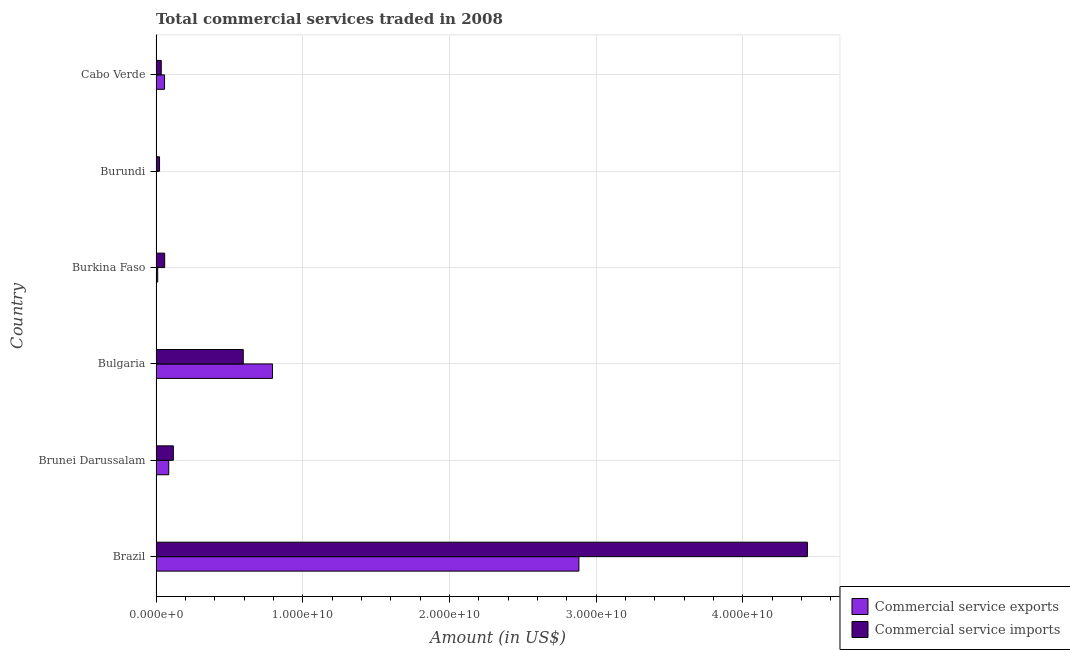How many bars are there on the 5th tick from the bottom?
Offer a terse response. 2. What is the label of the 6th group of bars from the top?
Your answer should be compact. Brazil. What is the amount of commercial service exports in Brazil?
Give a very brief answer. 2.88e+1. Across all countries, what is the maximum amount of commercial service exports?
Provide a short and direct response. 2.88e+1. Across all countries, what is the minimum amount of commercial service exports?
Offer a very short reply. 3.25e+06. In which country was the amount of commercial service exports minimum?
Ensure brevity in your answer.  Burundi. What is the total amount of commercial service imports in the graph?
Offer a terse response. 5.27e+1. What is the difference between the amount of commercial service imports in Brunei Darussalam and that in Burundi?
Your response must be concise. 9.41e+08. What is the difference between the amount of commercial service exports in Burkina Faso and the amount of commercial service imports in Cabo Verde?
Your answer should be compact. -2.42e+08. What is the average amount of commercial service imports per country?
Make the answer very short. 8.79e+09. What is the difference between the amount of commercial service imports and amount of commercial service exports in Cabo Verde?
Ensure brevity in your answer.  -2.24e+08. In how many countries, is the amount of commercial service exports greater than 36000000000 US$?
Keep it short and to the point. 0. What is the ratio of the amount of commercial service exports in Bulgaria to that in Burkina Faso?
Provide a short and direct response. 69.1. What is the difference between the highest and the second highest amount of commercial service exports?
Your answer should be very brief. 2.09e+1. What is the difference between the highest and the lowest amount of commercial service exports?
Provide a succinct answer. 2.88e+1. Is the sum of the amount of commercial service imports in Burkina Faso and Burundi greater than the maximum amount of commercial service exports across all countries?
Provide a succinct answer. No. What does the 1st bar from the top in Brazil represents?
Your answer should be compact. Commercial service imports. What does the 1st bar from the bottom in Cabo Verde represents?
Make the answer very short. Commercial service exports. How many countries are there in the graph?
Your answer should be very brief. 6. What is the difference between two consecutive major ticks on the X-axis?
Your answer should be compact. 1.00e+1. Are the values on the major ticks of X-axis written in scientific E-notation?
Provide a succinct answer. Yes. Does the graph contain any zero values?
Offer a terse response. No. Does the graph contain grids?
Your answer should be very brief. Yes. Where does the legend appear in the graph?
Provide a short and direct response. Bottom right. How are the legend labels stacked?
Give a very brief answer. Vertical. What is the title of the graph?
Make the answer very short. Total commercial services traded in 2008. What is the label or title of the Y-axis?
Your response must be concise. Country. What is the Amount (in US$) of Commercial service exports in Brazil?
Make the answer very short. 2.88e+1. What is the Amount (in US$) of Commercial service imports in Brazil?
Give a very brief answer. 4.44e+1. What is the Amount (in US$) of Commercial service exports in Brunei Darussalam?
Ensure brevity in your answer.  8.67e+08. What is the Amount (in US$) of Commercial service imports in Brunei Darussalam?
Give a very brief answer. 1.18e+09. What is the Amount (in US$) of Commercial service exports in Bulgaria?
Provide a succinct answer. 7.94e+09. What is the Amount (in US$) in Commercial service imports in Bulgaria?
Make the answer very short. 5.95e+09. What is the Amount (in US$) of Commercial service exports in Burkina Faso?
Offer a very short reply. 1.15e+08. What is the Amount (in US$) in Commercial service imports in Burkina Faso?
Your answer should be very brief. 5.90e+08. What is the Amount (in US$) of Commercial service exports in Burundi?
Provide a succinct answer. 3.25e+06. What is the Amount (in US$) of Commercial service imports in Burundi?
Offer a very short reply. 2.41e+08. What is the Amount (in US$) in Commercial service exports in Cabo Verde?
Offer a very short reply. 5.81e+08. What is the Amount (in US$) of Commercial service imports in Cabo Verde?
Your answer should be compact. 3.57e+08. Across all countries, what is the maximum Amount (in US$) in Commercial service exports?
Offer a very short reply. 2.88e+1. Across all countries, what is the maximum Amount (in US$) of Commercial service imports?
Offer a very short reply. 4.44e+1. Across all countries, what is the minimum Amount (in US$) in Commercial service exports?
Your response must be concise. 3.25e+06. Across all countries, what is the minimum Amount (in US$) of Commercial service imports?
Provide a succinct answer. 2.41e+08. What is the total Amount (in US$) in Commercial service exports in the graph?
Ensure brevity in your answer.  3.83e+1. What is the total Amount (in US$) of Commercial service imports in the graph?
Your answer should be compact. 5.27e+1. What is the difference between the Amount (in US$) in Commercial service exports in Brazil and that in Brunei Darussalam?
Keep it short and to the point. 2.80e+1. What is the difference between the Amount (in US$) of Commercial service imports in Brazil and that in Brunei Darussalam?
Ensure brevity in your answer.  4.32e+1. What is the difference between the Amount (in US$) of Commercial service exports in Brazil and that in Bulgaria?
Keep it short and to the point. 2.09e+1. What is the difference between the Amount (in US$) in Commercial service imports in Brazil and that in Bulgaria?
Make the answer very short. 3.85e+1. What is the difference between the Amount (in US$) in Commercial service exports in Brazil and that in Burkina Faso?
Offer a terse response. 2.87e+1. What is the difference between the Amount (in US$) in Commercial service imports in Brazil and that in Burkina Faso?
Ensure brevity in your answer.  4.38e+1. What is the difference between the Amount (in US$) of Commercial service exports in Brazil and that in Burundi?
Your answer should be compact. 2.88e+1. What is the difference between the Amount (in US$) of Commercial service imports in Brazil and that in Burundi?
Offer a very short reply. 4.42e+1. What is the difference between the Amount (in US$) of Commercial service exports in Brazil and that in Cabo Verde?
Give a very brief answer. 2.82e+1. What is the difference between the Amount (in US$) in Commercial service imports in Brazil and that in Cabo Verde?
Offer a terse response. 4.40e+1. What is the difference between the Amount (in US$) in Commercial service exports in Brunei Darussalam and that in Bulgaria?
Give a very brief answer. -7.07e+09. What is the difference between the Amount (in US$) in Commercial service imports in Brunei Darussalam and that in Bulgaria?
Keep it short and to the point. -4.76e+09. What is the difference between the Amount (in US$) of Commercial service exports in Brunei Darussalam and that in Burkina Faso?
Ensure brevity in your answer.  7.52e+08. What is the difference between the Amount (in US$) of Commercial service imports in Brunei Darussalam and that in Burkina Faso?
Provide a short and direct response. 5.91e+08. What is the difference between the Amount (in US$) of Commercial service exports in Brunei Darussalam and that in Burundi?
Your answer should be very brief. 8.64e+08. What is the difference between the Amount (in US$) of Commercial service imports in Brunei Darussalam and that in Burundi?
Offer a very short reply. 9.41e+08. What is the difference between the Amount (in US$) in Commercial service exports in Brunei Darussalam and that in Cabo Verde?
Ensure brevity in your answer.  2.86e+08. What is the difference between the Amount (in US$) in Commercial service imports in Brunei Darussalam and that in Cabo Verde?
Your answer should be very brief. 8.24e+08. What is the difference between the Amount (in US$) in Commercial service exports in Bulgaria and that in Burkina Faso?
Provide a succinct answer. 7.82e+09. What is the difference between the Amount (in US$) in Commercial service imports in Bulgaria and that in Burkina Faso?
Your response must be concise. 5.36e+09. What is the difference between the Amount (in US$) of Commercial service exports in Bulgaria and that in Burundi?
Make the answer very short. 7.94e+09. What is the difference between the Amount (in US$) in Commercial service imports in Bulgaria and that in Burundi?
Your response must be concise. 5.70e+09. What is the difference between the Amount (in US$) of Commercial service exports in Bulgaria and that in Cabo Verde?
Your response must be concise. 7.36e+09. What is the difference between the Amount (in US$) of Commercial service imports in Bulgaria and that in Cabo Verde?
Ensure brevity in your answer.  5.59e+09. What is the difference between the Amount (in US$) of Commercial service exports in Burkina Faso and that in Burundi?
Provide a short and direct response. 1.12e+08. What is the difference between the Amount (in US$) in Commercial service imports in Burkina Faso and that in Burundi?
Your answer should be compact. 3.50e+08. What is the difference between the Amount (in US$) in Commercial service exports in Burkina Faso and that in Cabo Verde?
Provide a succinct answer. -4.66e+08. What is the difference between the Amount (in US$) of Commercial service imports in Burkina Faso and that in Cabo Verde?
Provide a succinct answer. 2.33e+08. What is the difference between the Amount (in US$) in Commercial service exports in Burundi and that in Cabo Verde?
Give a very brief answer. -5.78e+08. What is the difference between the Amount (in US$) in Commercial service imports in Burundi and that in Cabo Verde?
Offer a terse response. -1.16e+08. What is the difference between the Amount (in US$) of Commercial service exports in Brazil and the Amount (in US$) of Commercial service imports in Brunei Darussalam?
Offer a very short reply. 2.76e+1. What is the difference between the Amount (in US$) of Commercial service exports in Brazil and the Amount (in US$) of Commercial service imports in Bulgaria?
Make the answer very short. 2.29e+1. What is the difference between the Amount (in US$) in Commercial service exports in Brazil and the Amount (in US$) in Commercial service imports in Burkina Faso?
Make the answer very short. 2.82e+1. What is the difference between the Amount (in US$) of Commercial service exports in Brazil and the Amount (in US$) of Commercial service imports in Burundi?
Provide a short and direct response. 2.86e+1. What is the difference between the Amount (in US$) in Commercial service exports in Brazil and the Amount (in US$) in Commercial service imports in Cabo Verde?
Make the answer very short. 2.85e+1. What is the difference between the Amount (in US$) in Commercial service exports in Brunei Darussalam and the Amount (in US$) in Commercial service imports in Bulgaria?
Your answer should be compact. -5.08e+09. What is the difference between the Amount (in US$) of Commercial service exports in Brunei Darussalam and the Amount (in US$) of Commercial service imports in Burkina Faso?
Your answer should be compact. 2.77e+08. What is the difference between the Amount (in US$) in Commercial service exports in Brunei Darussalam and the Amount (in US$) in Commercial service imports in Burundi?
Provide a short and direct response. 6.27e+08. What is the difference between the Amount (in US$) of Commercial service exports in Brunei Darussalam and the Amount (in US$) of Commercial service imports in Cabo Verde?
Provide a succinct answer. 5.10e+08. What is the difference between the Amount (in US$) in Commercial service exports in Bulgaria and the Amount (in US$) in Commercial service imports in Burkina Faso?
Your answer should be very brief. 7.35e+09. What is the difference between the Amount (in US$) of Commercial service exports in Bulgaria and the Amount (in US$) of Commercial service imports in Burundi?
Your response must be concise. 7.70e+09. What is the difference between the Amount (in US$) of Commercial service exports in Bulgaria and the Amount (in US$) of Commercial service imports in Cabo Verde?
Your response must be concise. 7.58e+09. What is the difference between the Amount (in US$) in Commercial service exports in Burkina Faso and the Amount (in US$) in Commercial service imports in Burundi?
Your answer should be very brief. -1.26e+08. What is the difference between the Amount (in US$) in Commercial service exports in Burkina Faso and the Amount (in US$) in Commercial service imports in Cabo Verde?
Offer a very short reply. -2.42e+08. What is the difference between the Amount (in US$) in Commercial service exports in Burundi and the Amount (in US$) in Commercial service imports in Cabo Verde?
Offer a terse response. -3.54e+08. What is the average Amount (in US$) in Commercial service exports per country?
Your answer should be very brief. 6.39e+09. What is the average Amount (in US$) of Commercial service imports per country?
Your response must be concise. 8.79e+09. What is the difference between the Amount (in US$) in Commercial service exports and Amount (in US$) in Commercial service imports in Brazil?
Your answer should be very brief. -1.56e+1. What is the difference between the Amount (in US$) in Commercial service exports and Amount (in US$) in Commercial service imports in Brunei Darussalam?
Your answer should be very brief. -3.14e+08. What is the difference between the Amount (in US$) in Commercial service exports and Amount (in US$) in Commercial service imports in Bulgaria?
Offer a terse response. 1.99e+09. What is the difference between the Amount (in US$) in Commercial service exports and Amount (in US$) in Commercial service imports in Burkina Faso?
Your response must be concise. -4.75e+08. What is the difference between the Amount (in US$) in Commercial service exports and Amount (in US$) in Commercial service imports in Burundi?
Provide a succinct answer. -2.37e+08. What is the difference between the Amount (in US$) of Commercial service exports and Amount (in US$) of Commercial service imports in Cabo Verde?
Your answer should be compact. 2.24e+08. What is the ratio of the Amount (in US$) of Commercial service exports in Brazil to that in Brunei Darussalam?
Keep it short and to the point. 33.23. What is the ratio of the Amount (in US$) of Commercial service imports in Brazil to that in Brunei Darussalam?
Give a very brief answer. 37.59. What is the ratio of the Amount (in US$) of Commercial service exports in Brazil to that in Bulgaria?
Your response must be concise. 3.63. What is the ratio of the Amount (in US$) in Commercial service imports in Brazil to that in Bulgaria?
Make the answer very short. 7.47. What is the ratio of the Amount (in US$) in Commercial service exports in Brazil to that in Burkina Faso?
Provide a short and direct response. 250.83. What is the ratio of the Amount (in US$) of Commercial service imports in Brazil to that in Burkina Faso?
Offer a terse response. 75.22. What is the ratio of the Amount (in US$) in Commercial service exports in Brazil to that in Burundi?
Provide a short and direct response. 8868.08. What is the ratio of the Amount (in US$) in Commercial service imports in Brazil to that in Burundi?
Your response must be concise. 184.6. What is the ratio of the Amount (in US$) of Commercial service exports in Brazil to that in Cabo Verde?
Offer a very short reply. 49.61. What is the ratio of the Amount (in US$) in Commercial service imports in Brazil to that in Cabo Verde?
Keep it short and to the point. 124.43. What is the ratio of the Amount (in US$) in Commercial service exports in Brunei Darussalam to that in Bulgaria?
Offer a terse response. 0.11. What is the ratio of the Amount (in US$) in Commercial service imports in Brunei Darussalam to that in Bulgaria?
Offer a very short reply. 0.2. What is the ratio of the Amount (in US$) of Commercial service exports in Brunei Darussalam to that in Burkina Faso?
Provide a short and direct response. 7.55. What is the ratio of the Amount (in US$) in Commercial service imports in Brunei Darussalam to that in Burkina Faso?
Ensure brevity in your answer.  2. What is the ratio of the Amount (in US$) of Commercial service exports in Brunei Darussalam to that in Burundi?
Provide a short and direct response. 266.84. What is the ratio of the Amount (in US$) of Commercial service imports in Brunei Darussalam to that in Burundi?
Provide a succinct answer. 4.91. What is the ratio of the Amount (in US$) in Commercial service exports in Brunei Darussalam to that in Cabo Verde?
Make the answer very short. 1.49. What is the ratio of the Amount (in US$) of Commercial service imports in Brunei Darussalam to that in Cabo Verde?
Your response must be concise. 3.31. What is the ratio of the Amount (in US$) of Commercial service exports in Bulgaria to that in Burkina Faso?
Keep it short and to the point. 69.1. What is the ratio of the Amount (in US$) of Commercial service imports in Bulgaria to that in Burkina Faso?
Give a very brief answer. 10.07. What is the ratio of the Amount (in US$) of Commercial service exports in Bulgaria to that in Burundi?
Give a very brief answer. 2442.85. What is the ratio of the Amount (in US$) of Commercial service imports in Bulgaria to that in Burundi?
Your response must be concise. 24.72. What is the ratio of the Amount (in US$) in Commercial service exports in Bulgaria to that in Cabo Verde?
Your answer should be compact. 13.66. What is the ratio of the Amount (in US$) in Commercial service imports in Bulgaria to that in Cabo Verde?
Give a very brief answer. 16.66. What is the ratio of the Amount (in US$) of Commercial service exports in Burkina Faso to that in Burundi?
Offer a terse response. 35.35. What is the ratio of the Amount (in US$) of Commercial service imports in Burkina Faso to that in Burundi?
Ensure brevity in your answer.  2.45. What is the ratio of the Amount (in US$) in Commercial service exports in Burkina Faso to that in Cabo Verde?
Keep it short and to the point. 0.2. What is the ratio of the Amount (in US$) in Commercial service imports in Burkina Faso to that in Cabo Verde?
Your response must be concise. 1.65. What is the ratio of the Amount (in US$) of Commercial service exports in Burundi to that in Cabo Verde?
Keep it short and to the point. 0.01. What is the ratio of the Amount (in US$) of Commercial service imports in Burundi to that in Cabo Verde?
Give a very brief answer. 0.67. What is the difference between the highest and the second highest Amount (in US$) in Commercial service exports?
Ensure brevity in your answer.  2.09e+1. What is the difference between the highest and the second highest Amount (in US$) of Commercial service imports?
Give a very brief answer. 3.85e+1. What is the difference between the highest and the lowest Amount (in US$) of Commercial service exports?
Make the answer very short. 2.88e+1. What is the difference between the highest and the lowest Amount (in US$) of Commercial service imports?
Provide a short and direct response. 4.42e+1. 